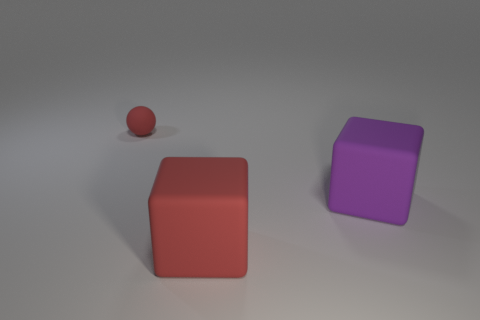How big is the thing that is behind the red cube and in front of the tiny red matte sphere?
Ensure brevity in your answer.  Large. Is the shape of the red rubber object behind the big purple block the same as  the purple object?
Offer a very short reply. No. There is a red thing in front of the red thing that is behind the red matte thing that is right of the tiny red object; how big is it?
Your answer should be very brief. Large. What is the size of the matte object that is the same color as the small rubber ball?
Provide a short and direct response. Large. How many things are red cubes or tiny rubber objects?
Offer a terse response. 2. The object that is left of the large purple matte object and behind the red block has what shape?
Your answer should be compact. Sphere. There is a large purple object; is its shape the same as the red object on the left side of the big red object?
Ensure brevity in your answer.  No. Are there any small red objects on the right side of the purple block?
Your answer should be compact. No. How many cubes are either small things or small cyan shiny objects?
Offer a very short reply. 0. Do the large purple matte object and the tiny thing have the same shape?
Your response must be concise. No. 